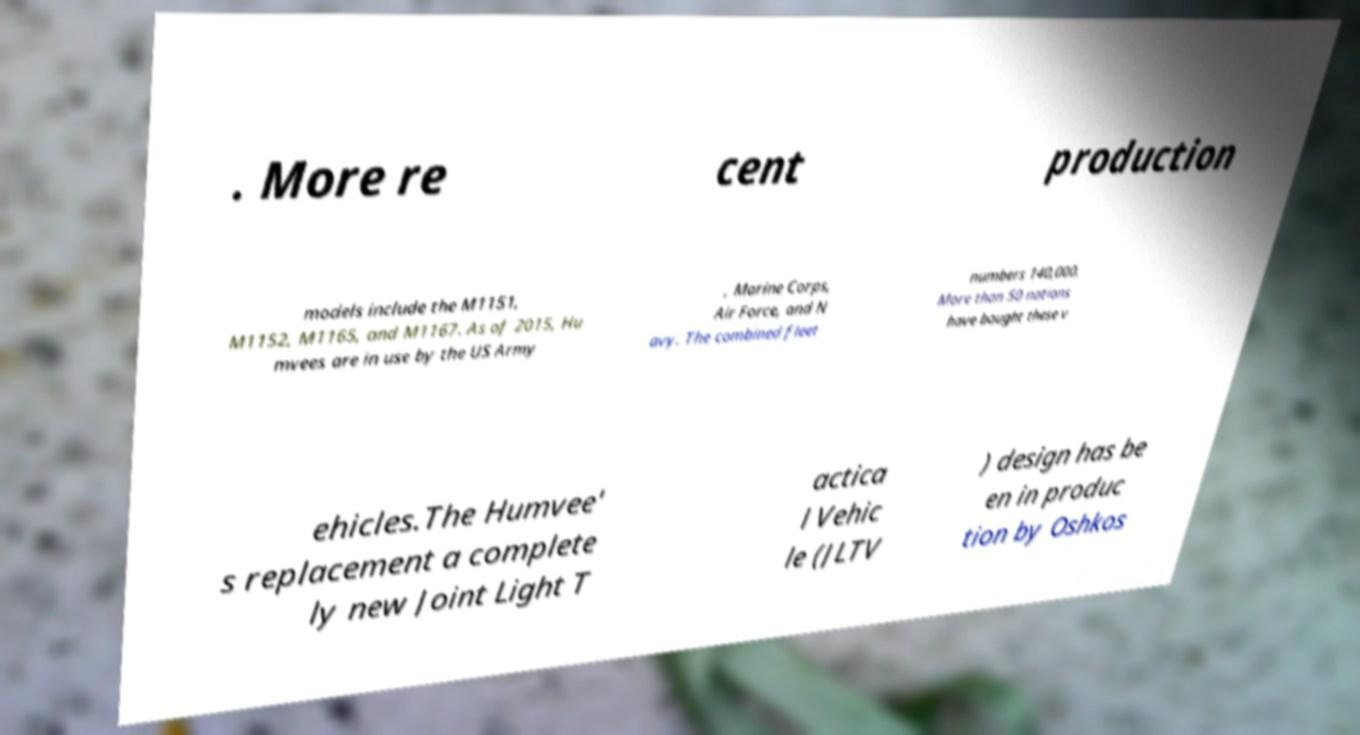There's text embedded in this image that I need extracted. Can you transcribe it verbatim? . More re cent production models include the M1151, M1152, M1165, and M1167. As of 2015, Hu mvees are in use by the US Army , Marine Corps, Air Force, and N avy. The combined fleet numbers 140,000. More than 50 nations have bought these v ehicles.The Humvee' s replacement a complete ly new Joint Light T actica l Vehic le (JLTV ) design has be en in produc tion by Oshkos 